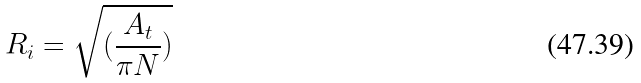Convert formula to latex. <formula><loc_0><loc_0><loc_500><loc_500>R _ { i } = \sqrt { ( \frac { A _ { t } } { \pi N } ) }</formula> 